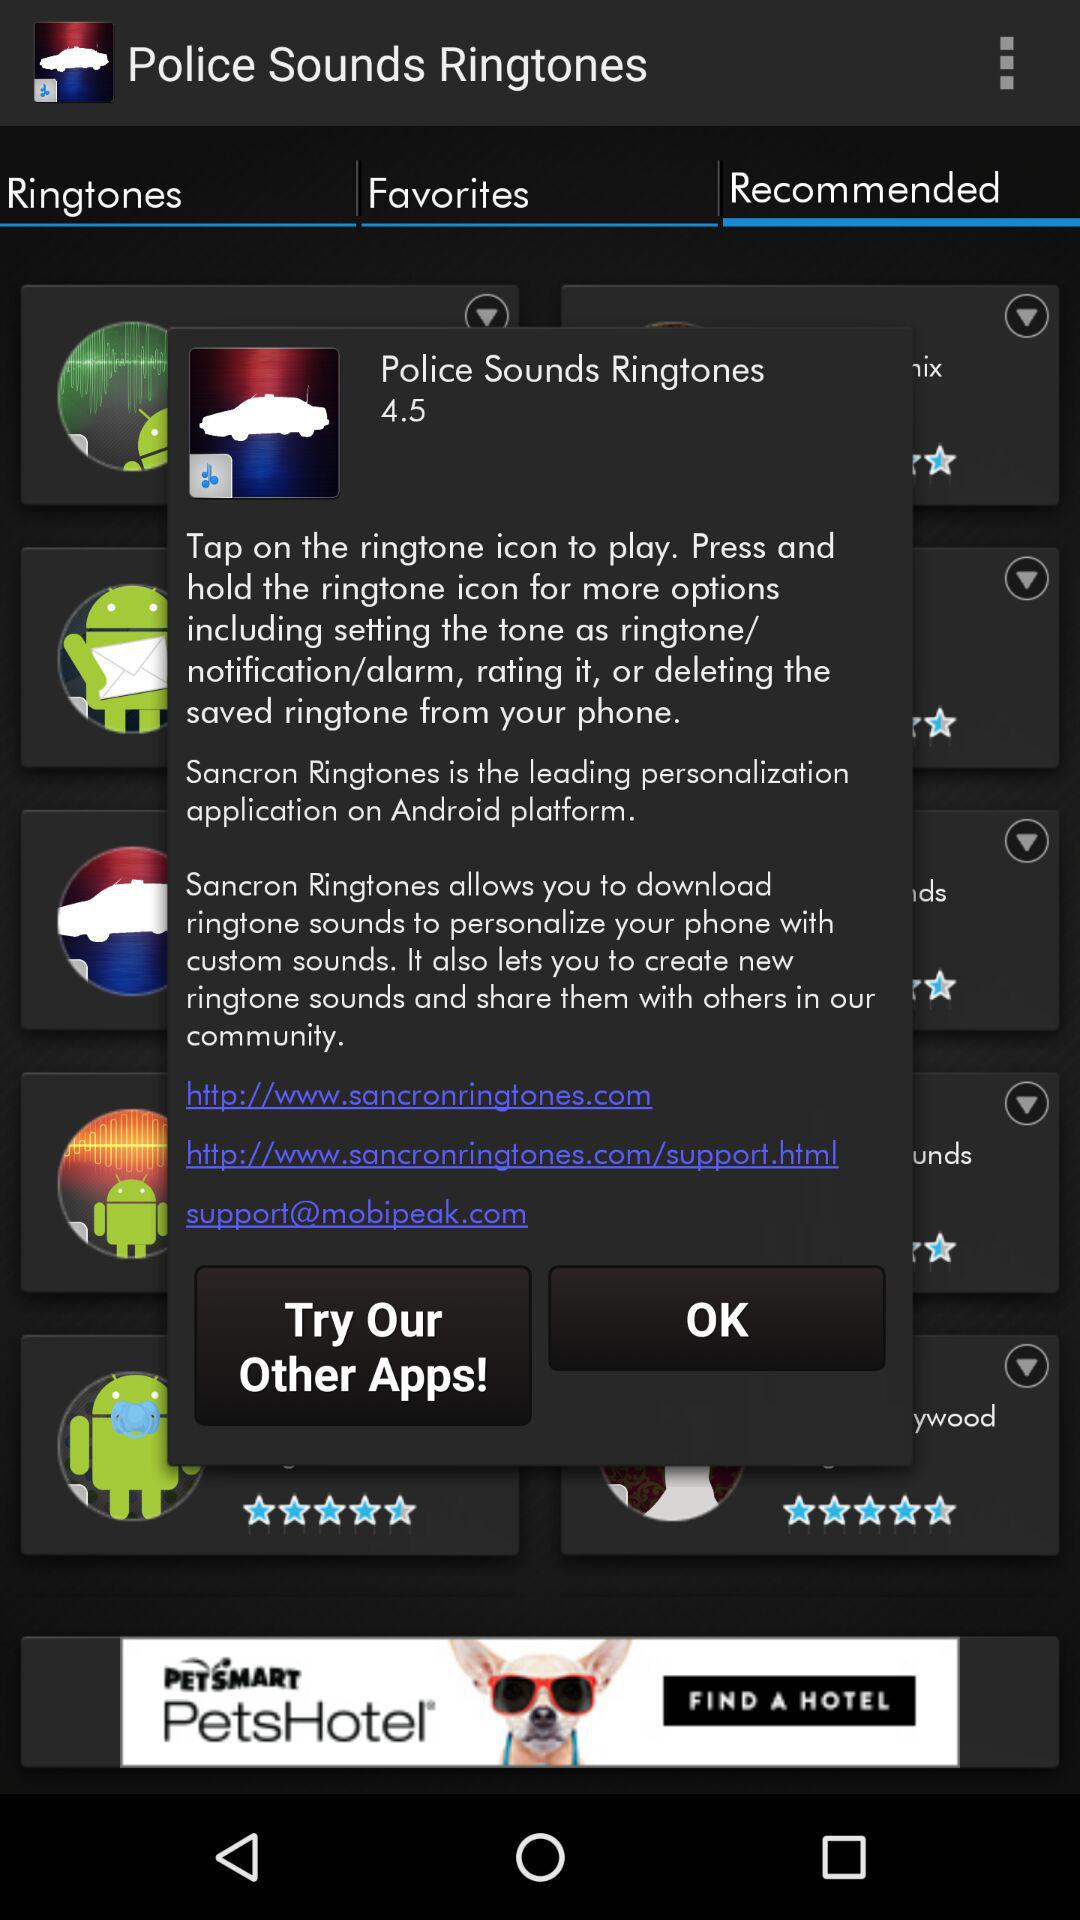What is the rating? The rating is 4.5. 